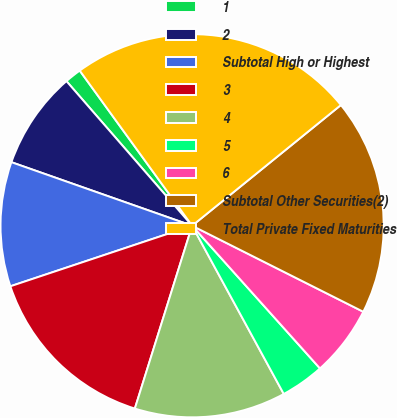Convert chart to OTSL. <chart><loc_0><loc_0><loc_500><loc_500><pie_chart><fcel>1<fcel>2<fcel>Subtotal High or Highest<fcel>3<fcel>4<fcel>5<fcel>6<fcel>Subtotal Other Securities(2)<fcel>Total Private Fixed Maturities<nl><fcel>1.41%<fcel>8.23%<fcel>10.5%<fcel>15.05%<fcel>12.77%<fcel>3.69%<fcel>5.96%<fcel>18.26%<fcel>24.13%<nl></chart> 